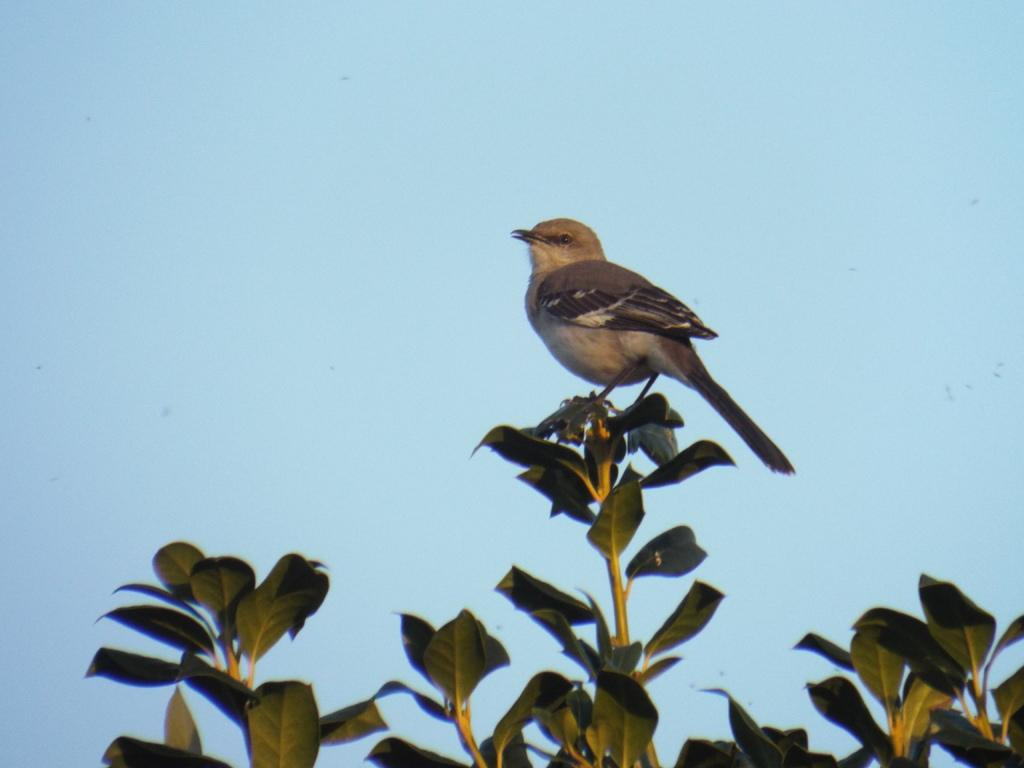What type of animal can be seen in the image? There is a bird in the image. Where is the bird located? The bird is on a tree stem. What is the process of the bird's unit in the image? There is no process or unit mentioned in the image; it simply shows a bird on a tree stem. 